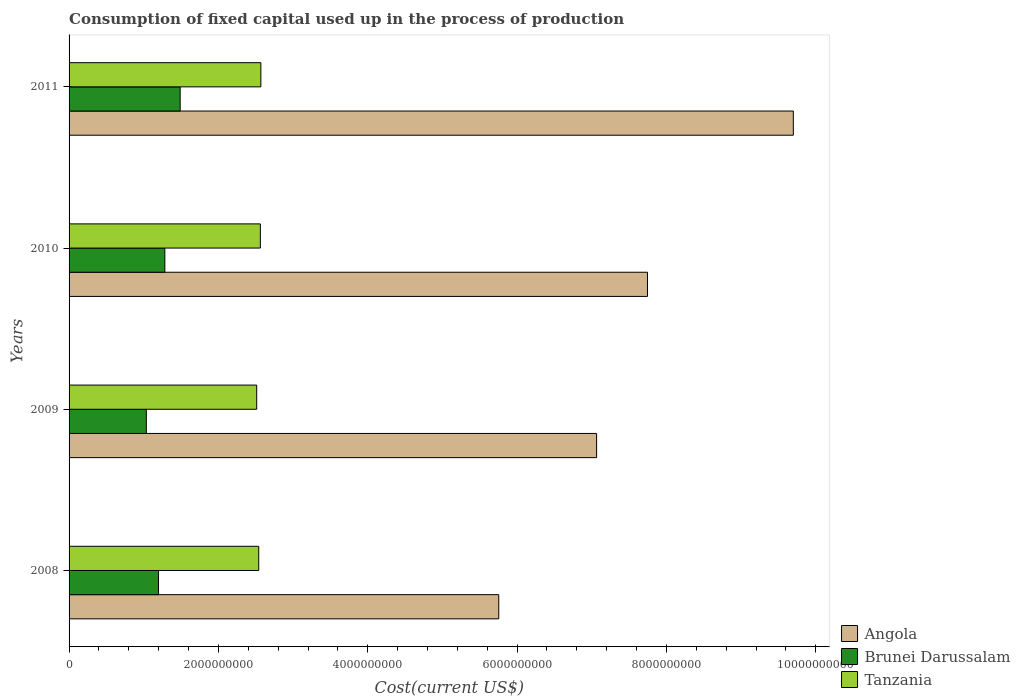How many different coloured bars are there?
Your answer should be very brief. 3. Are the number of bars on each tick of the Y-axis equal?
Make the answer very short. Yes. How many bars are there on the 1st tick from the top?
Your answer should be very brief. 3. What is the amount consumed in the process of production in Angola in 2008?
Provide a succinct answer. 5.75e+09. Across all years, what is the maximum amount consumed in the process of production in Brunei Darussalam?
Offer a terse response. 1.49e+09. Across all years, what is the minimum amount consumed in the process of production in Brunei Darussalam?
Offer a very short reply. 1.03e+09. In which year was the amount consumed in the process of production in Brunei Darussalam maximum?
Provide a succinct answer. 2011. What is the total amount consumed in the process of production in Angola in the graph?
Give a very brief answer. 3.03e+1. What is the difference between the amount consumed in the process of production in Angola in 2009 and that in 2010?
Provide a succinct answer. -6.82e+08. What is the difference between the amount consumed in the process of production in Tanzania in 2011 and the amount consumed in the process of production in Angola in 2008?
Offer a terse response. -3.19e+09. What is the average amount consumed in the process of production in Angola per year?
Offer a terse response. 7.57e+09. In the year 2010, what is the difference between the amount consumed in the process of production in Tanzania and amount consumed in the process of production in Brunei Darussalam?
Your answer should be very brief. 1.28e+09. What is the ratio of the amount consumed in the process of production in Tanzania in 2010 to that in 2011?
Your answer should be very brief. 1. Is the amount consumed in the process of production in Brunei Darussalam in 2008 less than that in 2011?
Give a very brief answer. Yes. Is the difference between the amount consumed in the process of production in Tanzania in 2008 and 2009 greater than the difference between the amount consumed in the process of production in Brunei Darussalam in 2008 and 2009?
Offer a very short reply. No. What is the difference between the highest and the second highest amount consumed in the process of production in Angola?
Give a very brief answer. 1.95e+09. What is the difference between the highest and the lowest amount consumed in the process of production in Tanzania?
Provide a short and direct response. 5.57e+07. In how many years, is the amount consumed in the process of production in Brunei Darussalam greater than the average amount consumed in the process of production in Brunei Darussalam taken over all years?
Offer a very short reply. 2. What does the 3rd bar from the top in 2010 represents?
Keep it short and to the point. Angola. What does the 3rd bar from the bottom in 2009 represents?
Provide a short and direct response. Tanzania. How many years are there in the graph?
Your answer should be compact. 4. What is the difference between two consecutive major ticks on the X-axis?
Make the answer very short. 2.00e+09. Does the graph contain grids?
Provide a succinct answer. No. How many legend labels are there?
Ensure brevity in your answer.  3. How are the legend labels stacked?
Ensure brevity in your answer.  Vertical. What is the title of the graph?
Provide a short and direct response. Consumption of fixed capital used up in the process of production. What is the label or title of the X-axis?
Provide a short and direct response. Cost(current US$). What is the label or title of the Y-axis?
Offer a terse response. Years. What is the Cost(current US$) of Angola in 2008?
Keep it short and to the point. 5.75e+09. What is the Cost(current US$) in Brunei Darussalam in 2008?
Offer a terse response. 1.20e+09. What is the Cost(current US$) in Tanzania in 2008?
Keep it short and to the point. 2.54e+09. What is the Cost(current US$) in Angola in 2009?
Your answer should be very brief. 7.07e+09. What is the Cost(current US$) of Brunei Darussalam in 2009?
Provide a succinct answer. 1.03e+09. What is the Cost(current US$) in Tanzania in 2009?
Ensure brevity in your answer.  2.51e+09. What is the Cost(current US$) in Angola in 2010?
Offer a terse response. 7.75e+09. What is the Cost(current US$) in Brunei Darussalam in 2010?
Keep it short and to the point. 1.28e+09. What is the Cost(current US$) of Tanzania in 2010?
Make the answer very short. 2.56e+09. What is the Cost(current US$) in Angola in 2011?
Ensure brevity in your answer.  9.70e+09. What is the Cost(current US$) of Brunei Darussalam in 2011?
Give a very brief answer. 1.49e+09. What is the Cost(current US$) of Tanzania in 2011?
Provide a short and direct response. 2.57e+09. Across all years, what is the maximum Cost(current US$) of Angola?
Your answer should be compact. 9.70e+09. Across all years, what is the maximum Cost(current US$) of Brunei Darussalam?
Offer a terse response. 1.49e+09. Across all years, what is the maximum Cost(current US$) of Tanzania?
Provide a short and direct response. 2.57e+09. Across all years, what is the minimum Cost(current US$) of Angola?
Your answer should be compact. 5.75e+09. Across all years, what is the minimum Cost(current US$) of Brunei Darussalam?
Your answer should be compact. 1.03e+09. Across all years, what is the minimum Cost(current US$) of Tanzania?
Keep it short and to the point. 2.51e+09. What is the total Cost(current US$) in Angola in the graph?
Ensure brevity in your answer.  3.03e+1. What is the total Cost(current US$) in Brunei Darussalam in the graph?
Your answer should be compact. 5.00e+09. What is the total Cost(current US$) in Tanzania in the graph?
Your answer should be very brief. 1.02e+1. What is the difference between the Cost(current US$) in Angola in 2008 and that in 2009?
Offer a terse response. -1.31e+09. What is the difference between the Cost(current US$) of Brunei Darussalam in 2008 and that in 2009?
Your response must be concise. 1.63e+08. What is the difference between the Cost(current US$) of Tanzania in 2008 and that in 2009?
Offer a terse response. 2.71e+07. What is the difference between the Cost(current US$) in Angola in 2008 and that in 2010?
Ensure brevity in your answer.  -1.99e+09. What is the difference between the Cost(current US$) of Brunei Darussalam in 2008 and that in 2010?
Keep it short and to the point. -8.48e+07. What is the difference between the Cost(current US$) in Tanzania in 2008 and that in 2010?
Keep it short and to the point. -2.16e+07. What is the difference between the Cost(current US$) of Angola in 2008 and that in 2011?
Make the answer very short. -3.94e+09. What is the difference between the Cost(current US$) in Brunei Darussalam in 2008 and that in 2011?
Give a very brief answer. -2.90e+08. What is the difference between the Cost(current US$) in Tanzania in 2008 and that in 2011?
Keep it short and to the point. -2.85e+07. What is the difference between the Cost(current US$) of Angola in 2009 and that in 2010?
Keep it short and to the point. -6.82e+08. What is the difference between the Cost(current US$) in Brunei Darussalam in 2009 and that in 2010?
Provide a short and direct response. -2.48e+08. What is the difference between the Cost(current US$) of Tanzania in 2009 and that in 2010?
Ensure brevity in your answer.  -4.87e+07. What is the difference between the Cost(current US$) of Angola in 2009 and that in 2011?
Ensure brevity in your answer.  -2.63e+09. What is the difference between the Cost(current US$) in Brunei Darussalam in 2009 and that in 2011?
Ensure brevity in your answer.  -4.53e+08. What is the difference between the Cost(current US$) in Tanzania in 2009 and that in 2011?
Offer a terse response. -5.57e+07. What is the difference between the Cost(current US$) of Angola in 2010 and that in 2011?
Your response must be concise. -1.95e+09. What is the difference between the Cost(current US$) in Brunei Darussalam in 2010 and that in 2011?
Offer a very short reply. -2.05e+08. What is the difference between the Cost(current US$) of Tanzania in 2010 and that in 2011?
Provide a short and direct response. -6.95e+06. What is the difference between the Cost(current US$) in Angola in 2008 and the Cost(current US$) in Brunei Darussalam in 2009?
Provide a succinct answer. 4.72e+09. What is the difference between the Cost(current US$) in Angola in 2008 and the Cost(current US$) in Tanzania in 2009?
Provide a short and direct response. 3.24e+09. What is the difference between the Cost(current US$) of Brunei Darussalam in 2008 and the Cost(current US$) of Tanzania in 2009?
Your answer should be very brief. -1.32e+09. What is the difference between the Cost(current US$) in Angola in 2008 and the Cost(current US$) in Brunei Darussalam in 2010?
Make the answer very short. 4.47e+09. What is the difference between the Cost(current US$) in Angola in 2008 and the Cost(current US$) in Tanzania in 2010?
Your answer should be compact. 3.19e+09. What is the difference between the Cost(current US$) of Brunei Darussalam in 2008 and the Cost(current US$) of Tanzania in 2010?
Keep it short and to the point. -1.36e+09. What is the difference between the Cost(current US$) of Angola in 2008 and the Cost(current US$) of Brunei Darussalam in 2011?
Give a very brief answer. 4.27e+09. What is the difference between the Cost(current US$) of Angola in 2008 and the Cost(current US$) of Tanzania in 2011?
Offer a terse response. 3.19e+09. What is the difference between the Cost(current US$) in Brunei Darussalam in 2008 and the Cost(current US$) in Tanzania in 2011?
Your answer should be very brief. -1.37e+09. What is the difference between the Cost(current US$) of Angola in 2009 and the Cost(current US$) of Brunei Darussalam in 2010?
Provide a succinct answer. 5.78e+09. What is the difference between the Cost(current US$) in Angola in 2009 and the Cost(current US$) in Tanzania in 2010?
Your answer should be very brief. 4.50e+09. What is the difference between the Cost(current US$) in Brunei Darussalam in 2009 and the Cost(current US$) in Tanzania in 2010?
Give a very brief answer. -1.53e+09. What is the difference between the Cost(current US$) in Angola in 2009 and the Cost(current US$) in Brunei Darussalam in 2011?
Provide a succinct answer. 5.58e+09. What is the difference between the Cost(current US$) in Angola in 2009 and the Cost(current US$) in Tanzania in 2011?
Provide a short and direct response. 4.50e+09. What is the difference between the Cost(current US$) in Brunei Darussalam in 2009 and the Cost(current US$) in Tanzania in 2011?
Ensure brevity in your answer.  -1.53e+09. What is the difference between the Cost(current US$) of Angola in 2010 and the Cost(current US$) of Brunei Darussalam in 2011?
Provide a succinct answer. 6.26e+09. What is the difference between the Cost(current US$) of Angola in 2010 and the Cost(current US$) of Tanzania in 2011?
Your answer should be compact. 5.18e+09. What is the difference between the Cost(current US$) in Brunei Darussalam in 2010 and the Cost(current US$) in Tanzania in 2011?
Offer a terse response. -1.29e+09. What is the average Cost(current US$) of Angola per year?
Your answer should be very brief. 7.57e+09. What is the average Cost(current US$) in Brunei Darussalam per year?
Offer a terse response. 1.25e+09. What is the average Cost(current US$) of Tanzania per year?
Offer a very short reply. 2.55e+09. In the year 2008, what is the difference between the Cost(current US$) in Angola and Cost(current US$) in Brunei Darussalam?
Offer a terse response. 4.56e+09. In the year 2008, what is the difference between the Cost(current US$) of Angola and Cost(current US$) of Tanzania?
Your response must be concise. 3.21e+09. In the year 2008, what is the difference between the Cost(current US$) in Brunei Darussalam and Cost(current US$) in Tanzania?
Offer a very short reply. -1.34e+09. In the year 2009, what is the difference between the Cost(current US$) in Angola and Cost(current US$) in Brunei Darussalam?
Keep it short and to the point. 6.03e+09. In the year 2009, what is the difference between the Cost(current US$) in Angola and Cost(current US$) in Tanzania?
Provide a succinct answer. 4.55e+09. In the year 2009, what is the difference between the Cost(current US$) in Brunei Darussalam and Cost(current US$) in Tanzania?
Offer a very short reply. -1.48e+09. In the year 2010, what is the difference between the Cost(current US$) of Angola and Cost(current US$) of Brunei Darussalam?
Offer a terse response. 6.46e+09. In the year 2010, what is the difference between the Cost(current US$) in Angola and Cost(current US$) in Tanzania?
Ensure brevity in your answer.  5.19e+09. In the year 2010, what is the difference between the Cost(current US$) of Brunei Darussalam and Cost(current US$) of Tanzania?
Your answer should be compact. -1.28e+09. In the year 2011, what is the difference between the Cost(current US$) of Angola and Cost(current US$) of Brunei Darussalam?
Give a very brief answer. 8.21e+09. In the year 2011, what is the difference between the Cost(current US$) in Angola and Cost(current US$) in Tanzania?
Provide a short and direct response. 7.13e+09. In the year 2011, what is the difference between the Cost(current US$) in Brunei Darussalam and Cost(current US$) in Tanzania?
Offer a terse response. -1.08e+09. What is the ratio of the Cost(current US$) in Angola in 2008 to that in 2009?
Your response must be concise. 0.81. What is the ratio of the Cost(current US$) in Brunei Darussalam in 2008 to that in 2009?
Your response must be concise. 1.16. What is the ratio of the Cost(current US$) in Tanzania in 2008 to that in 2009?
Keep it short and to the point. 1.01. What is the ratio of the Cost(current US$) of Angola in 2008 to that in 2010?
Your answer should be very brief. 0.74. What is the ratio of the Cost(current US$) of Brunei Darussalam in 2008 to that in 2010?
Keep it short and to the point. 0.93. What is the ratio of the Cost(current US$) in Angola in 2008 to that in 2011?
Give a very brief answer. 0.59. What is the ratio of the Cost(current US$) of Brunei Darussalam in 2008 to that in 2011?
Offer a terse response. 0.81. What is the ratio of the Cost(current US$) in Tanzania in 2008 to that in 2011?
Provide a succinct answer. 0.99. What is the ratio of the Cost(current US$) in Angola in 2009 to that in 2010?
Offer a terse response. 0.91. What is the ratio of the Cost(current US$) of Brunei Darussalam in 2009 to that in 2010?
Keep it short and to the point. 0.81. What is the ratio of the Cost(current US$) of Angola in 2009 to that in 2011?
Provide a succinct answer. 0.73. What is the ratio of the Cost(current US$) of Brunei Darussalam in 2009 to that in 2011?
Your response must be concise. 0.7. What is the ratio of the Cost(current US$) in Tanzania in 2009 to that in 2011?
Keep it short and to the point. 0.98. What is the ratio of the Cost(current US$) of Angola in 2010 to that in 2011?
Your answer should be compact. 0.8. What is the ratio of the Cost(current US$) of Brunei Darussalam in 2010 to that in 2011?
Give a very brief answer. 0.86. What is the difference between the highest and the second highest Cost(current US$) in Angola?
Provide a succinct answer. 1.95e+09. What is the difference between the highest and the second highest Cost(current US$) of Brunei Darussalam?
Ensure brevity in your answer.  2.05e+08. What is the difference between the highest and the second highest Cost(current US$) in Tanzania?
Give a very brief answer. 6.95e+06. What is the difference between the highest and the lowest Cost(current US$) of Angola?
Your answer should be compact. 3.94e+09. What is the difference between the highest and the lowest Cost(current US$) of Brunei Darussalam?
Your response must be concise. 4.53e+08. What is the difference between the highest and the lowest Cost(current US$) of Tanzania?
Offer a very short reply. 5.57e+07. 